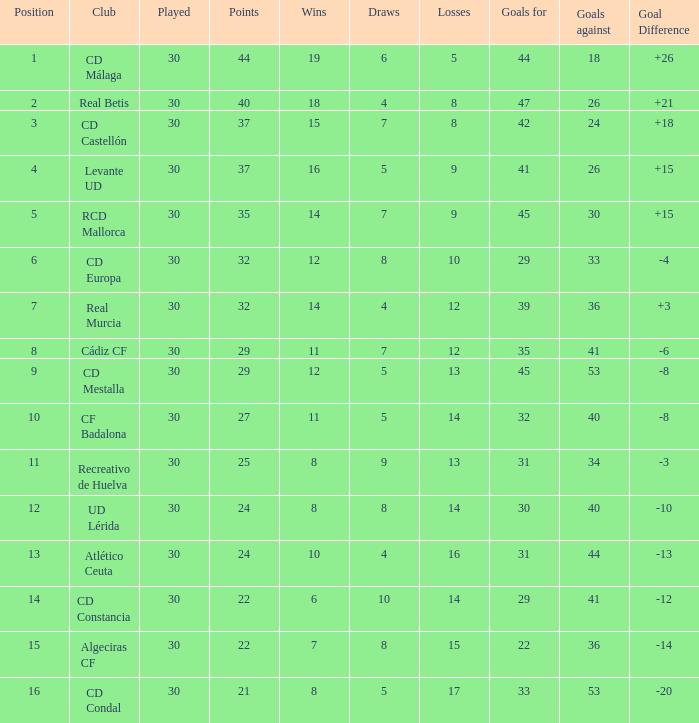What is the losses when the goal difference is larger than 26? None. 